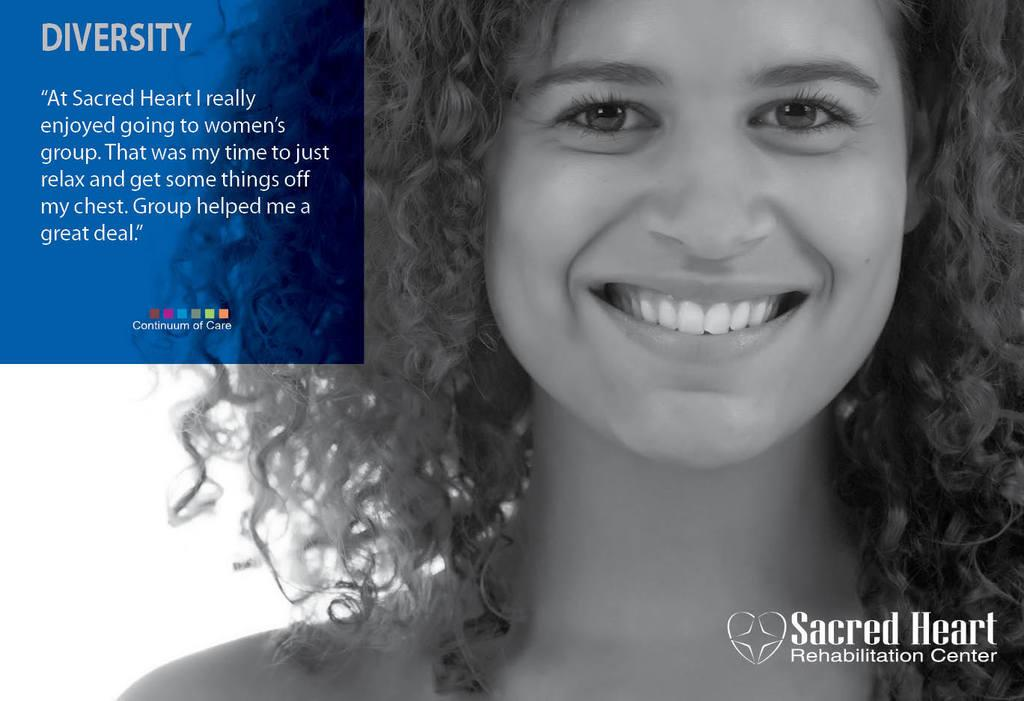What is present in the image related to advertising or information? There is a poster in the image. Can you describe the person featured on the poster? The poster features a woman with a smile on her face. What else can be seen on the poster besides the image of the woman? There is text written on the poster. What type of suit is the woman wearing in the image? There is no suit visible in the image; the woman is featured on a poster with text. What material is the straw made of in the image? There is no straw present in the image; it features a poster with a woman and text. 